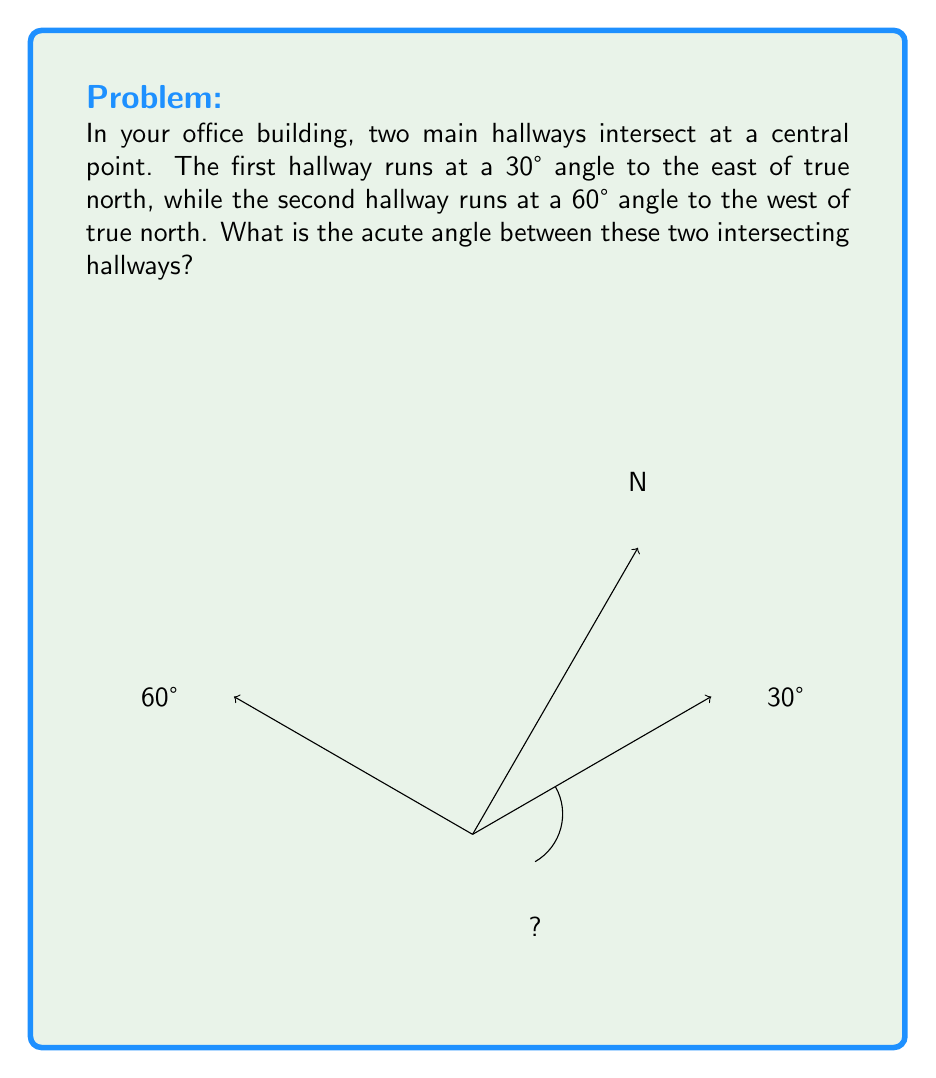What is the answer to this math problem? To find the acute angle between the two intersecting hallways, we need to follow these steps:

1. Understand the given information:
   - Hallway 1: 30° east of true north
   - Hallway 2: 60° west of true north

2. Visualize the problem:
   - Both angles are measured from true north
   - The total angle between the hallways is the sum of these two angles

3. Calculate the total angle:
   $\text{Total angle} = 30° + 60° = 90°$

4. Determine if this is the acute angle:
   - An acute angle is less than 90°
   - 90° is not an acute angle, it's a right angle

5. Find the acute angle:
   - The acute angle is the smaller of the two angles formed by the intersecting hallways
   - In a right angle, the acute angle is the complement of 90°
   - $\text{Acute angle} = 180° - 90° = 90°$

Therefore, the acute angle between the two intersecting hallways is 90°.
Answer: 90° 